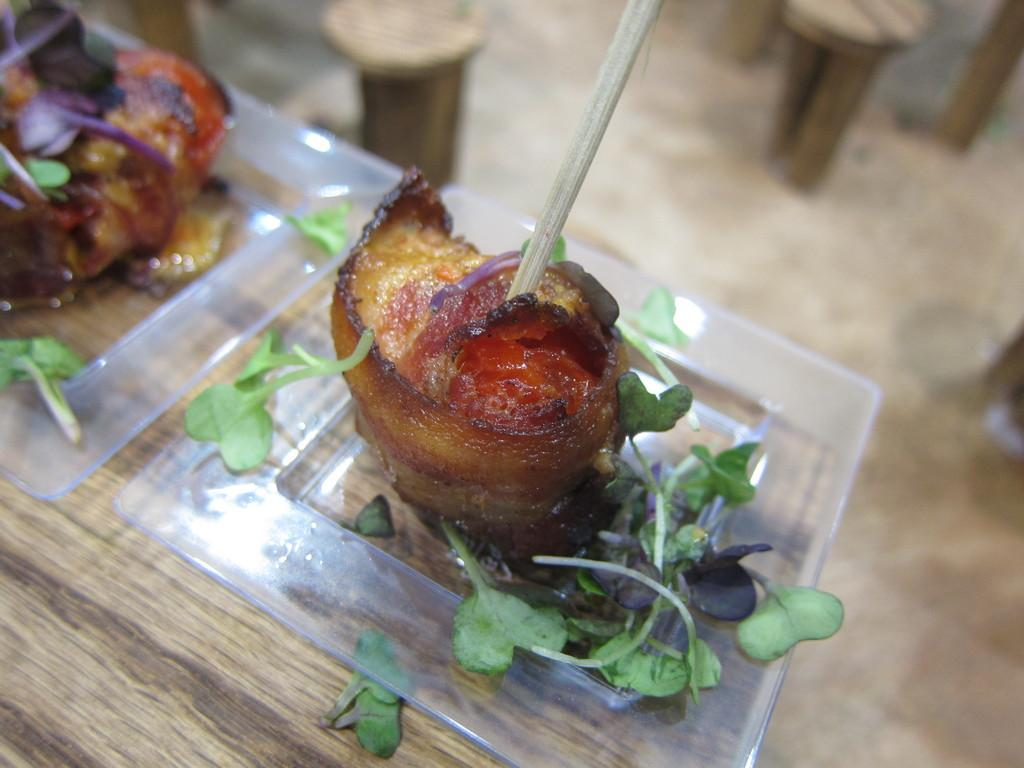What is on the glass plate in the image? There are food items on a glass plate in the image. What is the glass plate placed on? The glass plate is placed on a wooden surface. Can you describe the background of the image? The background of the image is blurred. Are there any objects visible in the background? Yes, there are objects visible in the background. What type of road can be seen in the background of the image? There is no road visible in the background of the image; it is blurred and only objects can be seen. 